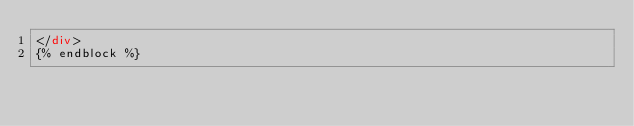Convert code to text. <code><loc_0><loc_0><loc_500><loc_500><_HTML_></div>
{% endblock %}
</code> 